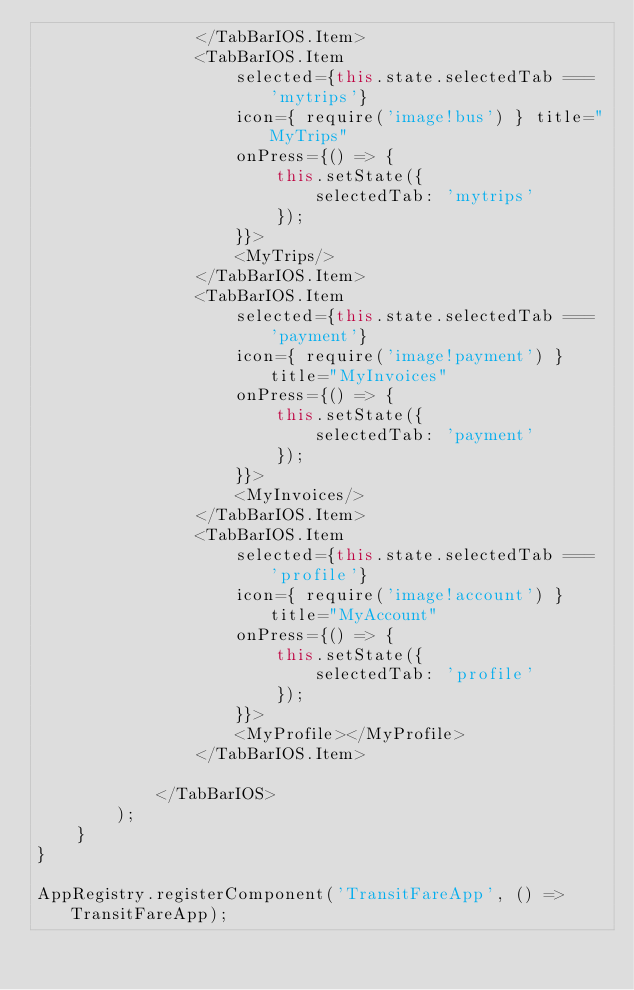Convert code to text. <code><loc_0><loc_0><loc_500><loc_500><_JavaScript_>                </TabBarIOS.Item>
                <TabBarIOS.Item
                    selected={this.state.selectedTab === 'mytrips'}
                    icon={ require('image!bus') } title="MyTrips"
                    onPress={() => {
                        this.setState({
                            selectedTab: 'mytrips'
                        });
                    }}>
                    <MyTrips/>
                </TabBarIOS.Item>
                <TabBarIOS.Item
                    selected={this.state.selectedTab === 'payment'}
                    icon={ require('image!payment') } title="MyInvoices"
                    onPress={() => {
                        this.setState({
                            selectedTab: 'payment'
                        });
                    }}>
                    <MyInvoices/>
                </TabBarIOS.Item>
                <TabBarIOS.Item
                    selected={this.state.selectedTab === 'profile'}
                    icon={ require('image!account') } title="MyAccount"
                    onPress={() => {
                        this.setState({
                            selectedTab: 'profile'
                        });
                    }}>
                    <MyProfile></MyProfile>
                </TabBarIOS.Item>
                
            </TabBarIOS>
        );
    }
}

AppRegistry.registerComponent('TransitFareApp', () => TransitFareApp);</code> 